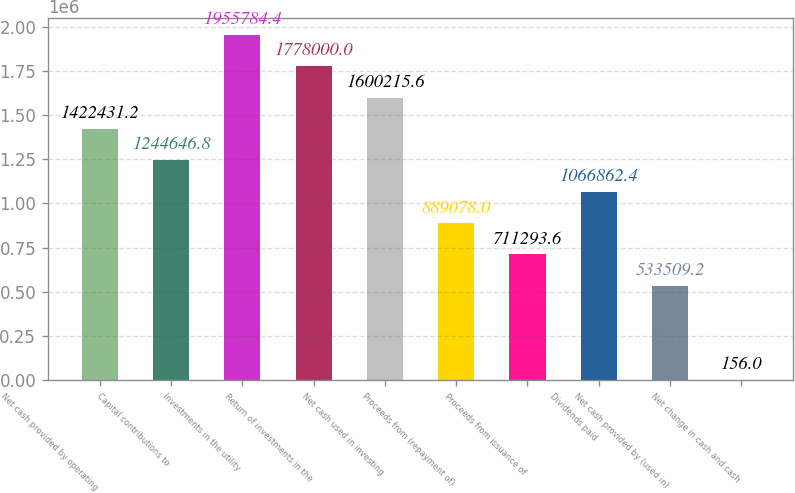<chart> <loc_0><loc_0><loc_500><loc_500><bar_chart><fcel>Net cash provided by operating<fcel>Capital contributions to<fcel>Investments in the utility<fcel>Return of investments in the<fcel>Net cash used in investing<fcel>Proceeds from (repayment of)<fcel>Proceeds from issuance of<fcel>Dividends paid<fcel>Net cash provided by (used in)<fcel>Net change in cash and cash<nl><fcel>1.42243e+06<fcel>1.24465e+06<fcel>1.95578e+06<fcel>1.778e+06<fcel>1.60022e+06<fcel>889078<fcel>711294<fcel>1.06686e+06<fcel>533509<fcel>156<nl></chart> 